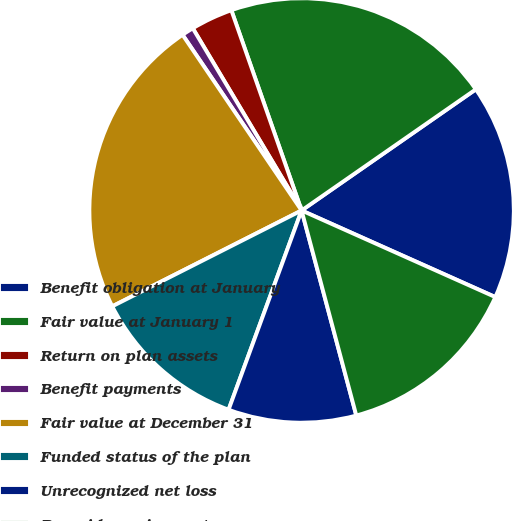<chart> <loc_0><loc_0><loc_500><loc_500><pie_chart><fcel>Benefit obligation at January<fcel>Fair value at January 1<fcel>Return on plan assets<fcel>Benefit payments<fcel>Fair value at December 31<fcel>Funded status of the plan<fcel>Unrecognized net loss<fcel>Prepaid pension cost<nl><fcel>16.36%<fcel>20.7%<fcel>3.2%<fcel>0.91%<fcel>22.98%<fcel>11.95%<fcel>9.74%<fcel>14.16%<nl></chart> 